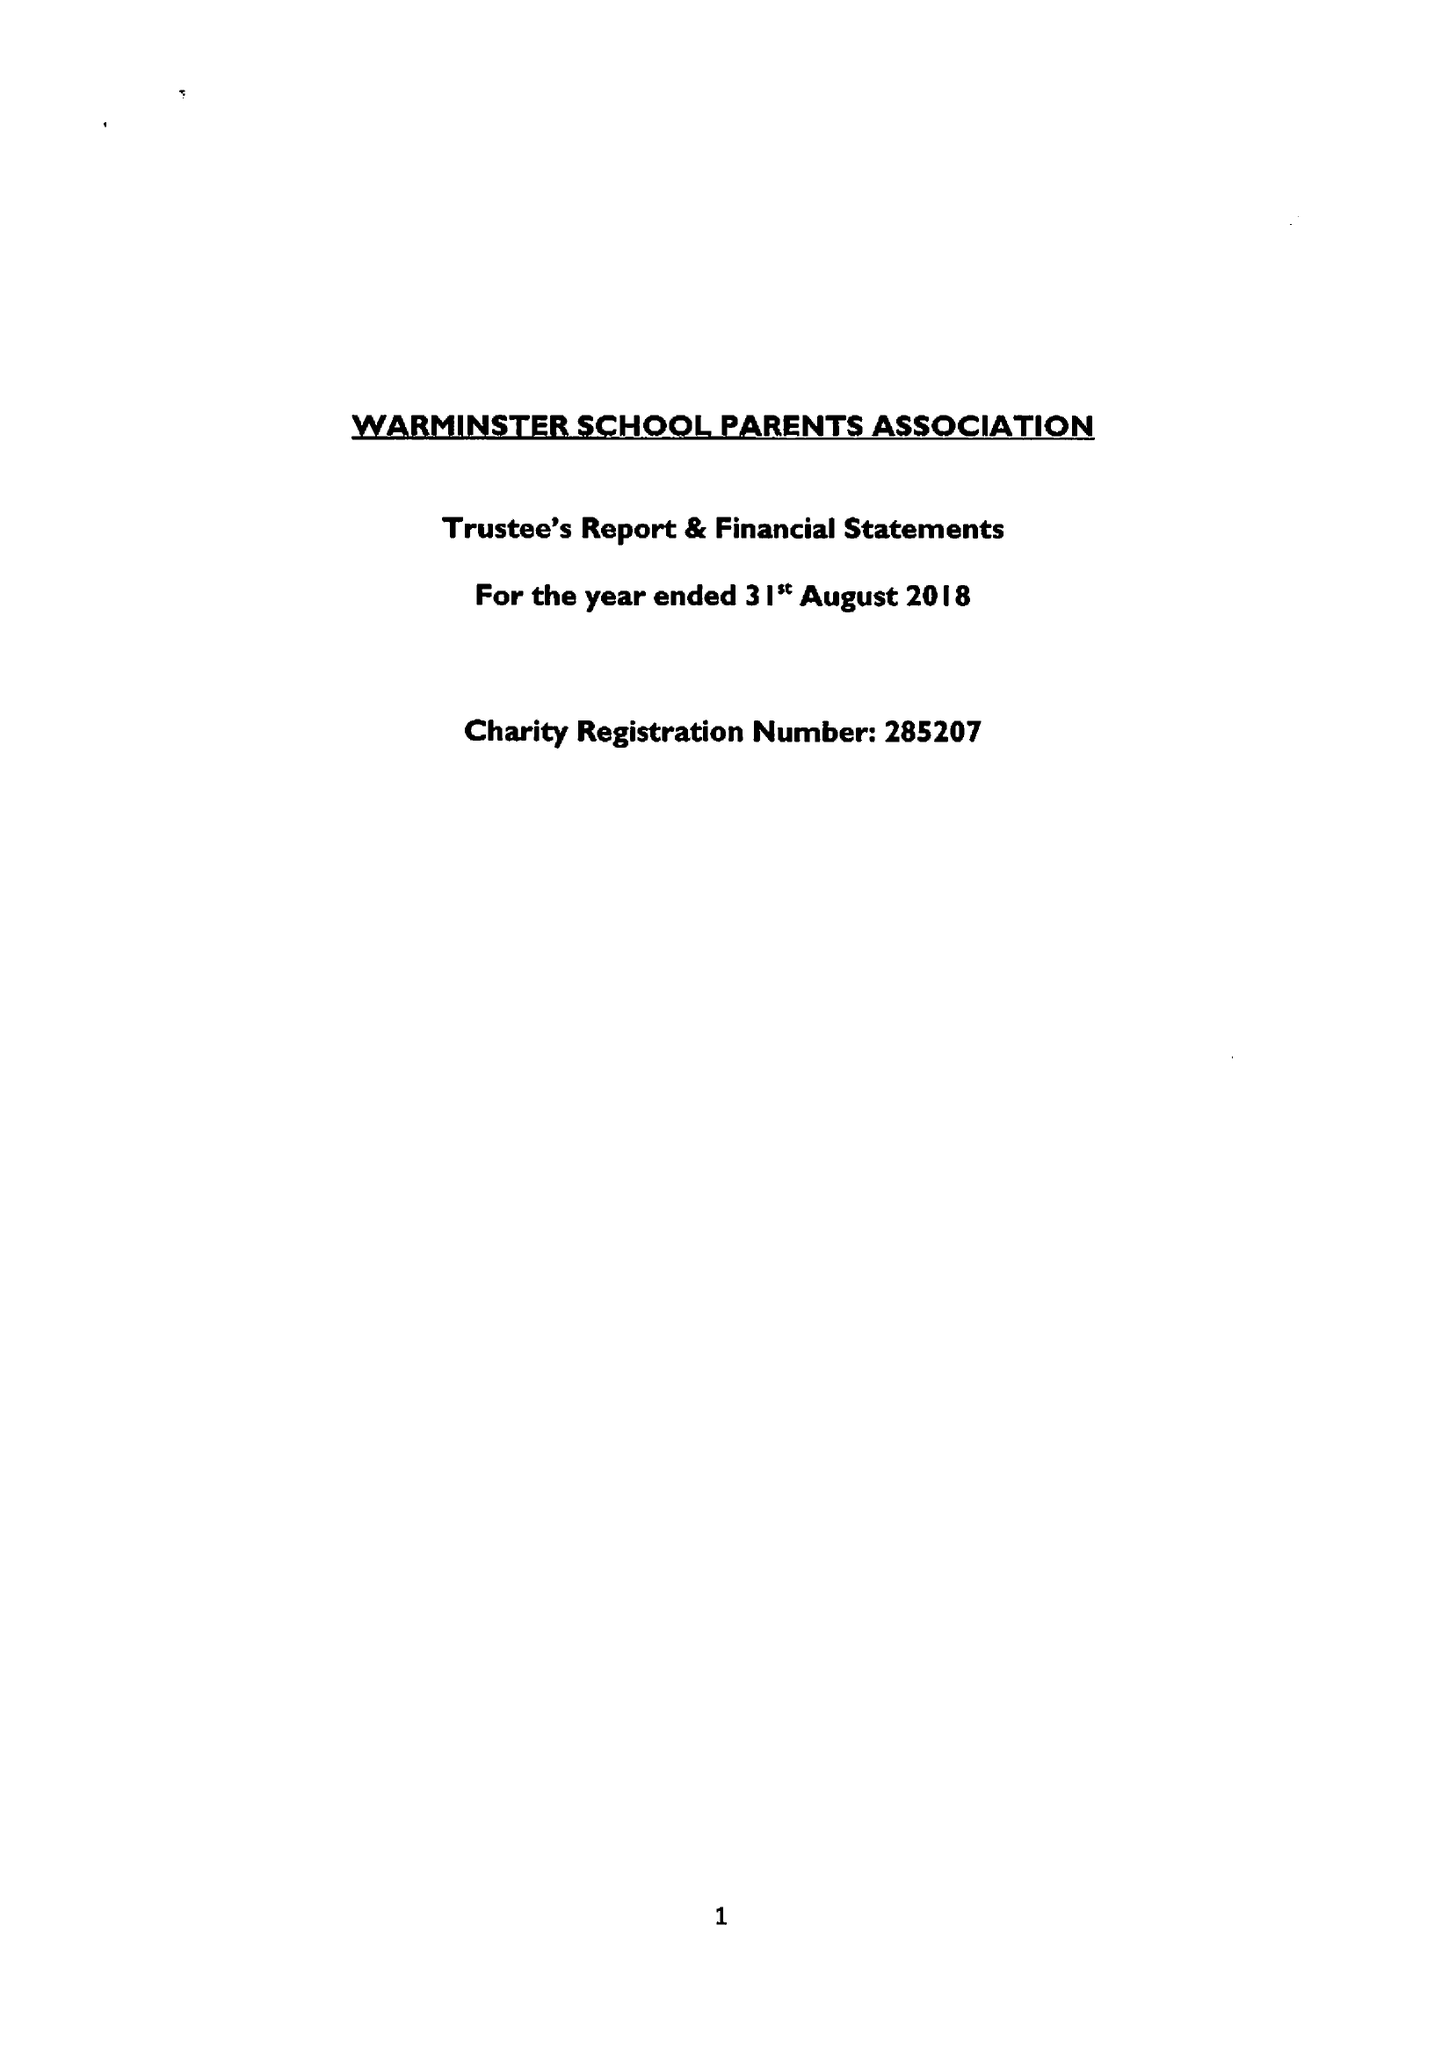What is the value for the report_date?
Answer the question using a single word or phrase. 2018-08-31 